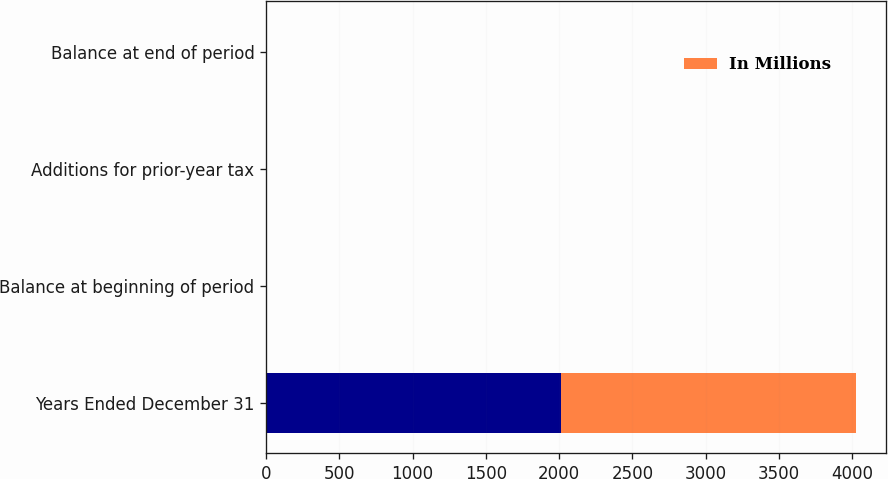Convert chart to OTSL. <chart><loc_0><loc_0><loc_500><loc_500><stacked_bar_chart><ecel><fcel>Years Ended December 31<fcel>Balance at beginning of period<fcel>Additions for prior-year tax<fcel>Balance at end of period<nl><fcel>nan<fcel>2014<fcel>4<fcel>1<fcel>5<nl><fcel>In Millions<fcel>2013<fcel>1<fcel>3<fcel>4<nl></chart> 